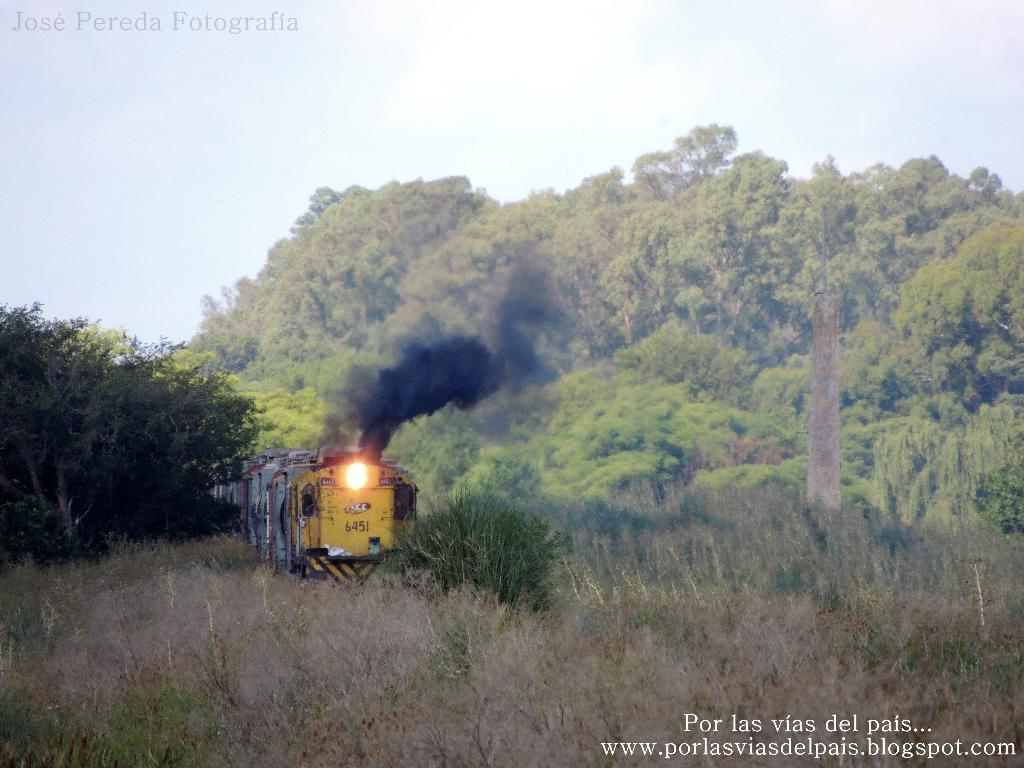What type of vegetation can be seen in the image? There are green color trees in the image. What is the condition of the ground in the image? There is dry grass in the image. What mode of transportation is present in the image? There is a train in the image, with yellow and white colors. What colors are visible in the sky in the image? The sky is blue and white in the image. What type of alarm can be heard in the image? There is no alarm present in the image, as it is a visual representation and not an audio recording. What team is responsible for maintaining the train in the image? There is no information about a team responsible for maintaining the train in the image. 